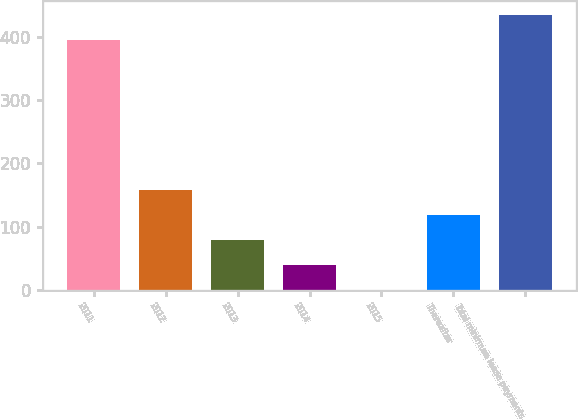Convert chart to OTSL. <chart><loc_0><loc_0><loc_500><loc_500><bar_chart><fcel>2011<fcel>2012<fcel>2013<fcel>2014<fcel>2015<fcel>Thereafter<fcel>Total minimum lease payments<nl><fcel>395<fcel>158.13<fcel>79.17<fcel>39.69<fcel>0.21<fcel>118.65<fcel>434.48<nl></chart> 